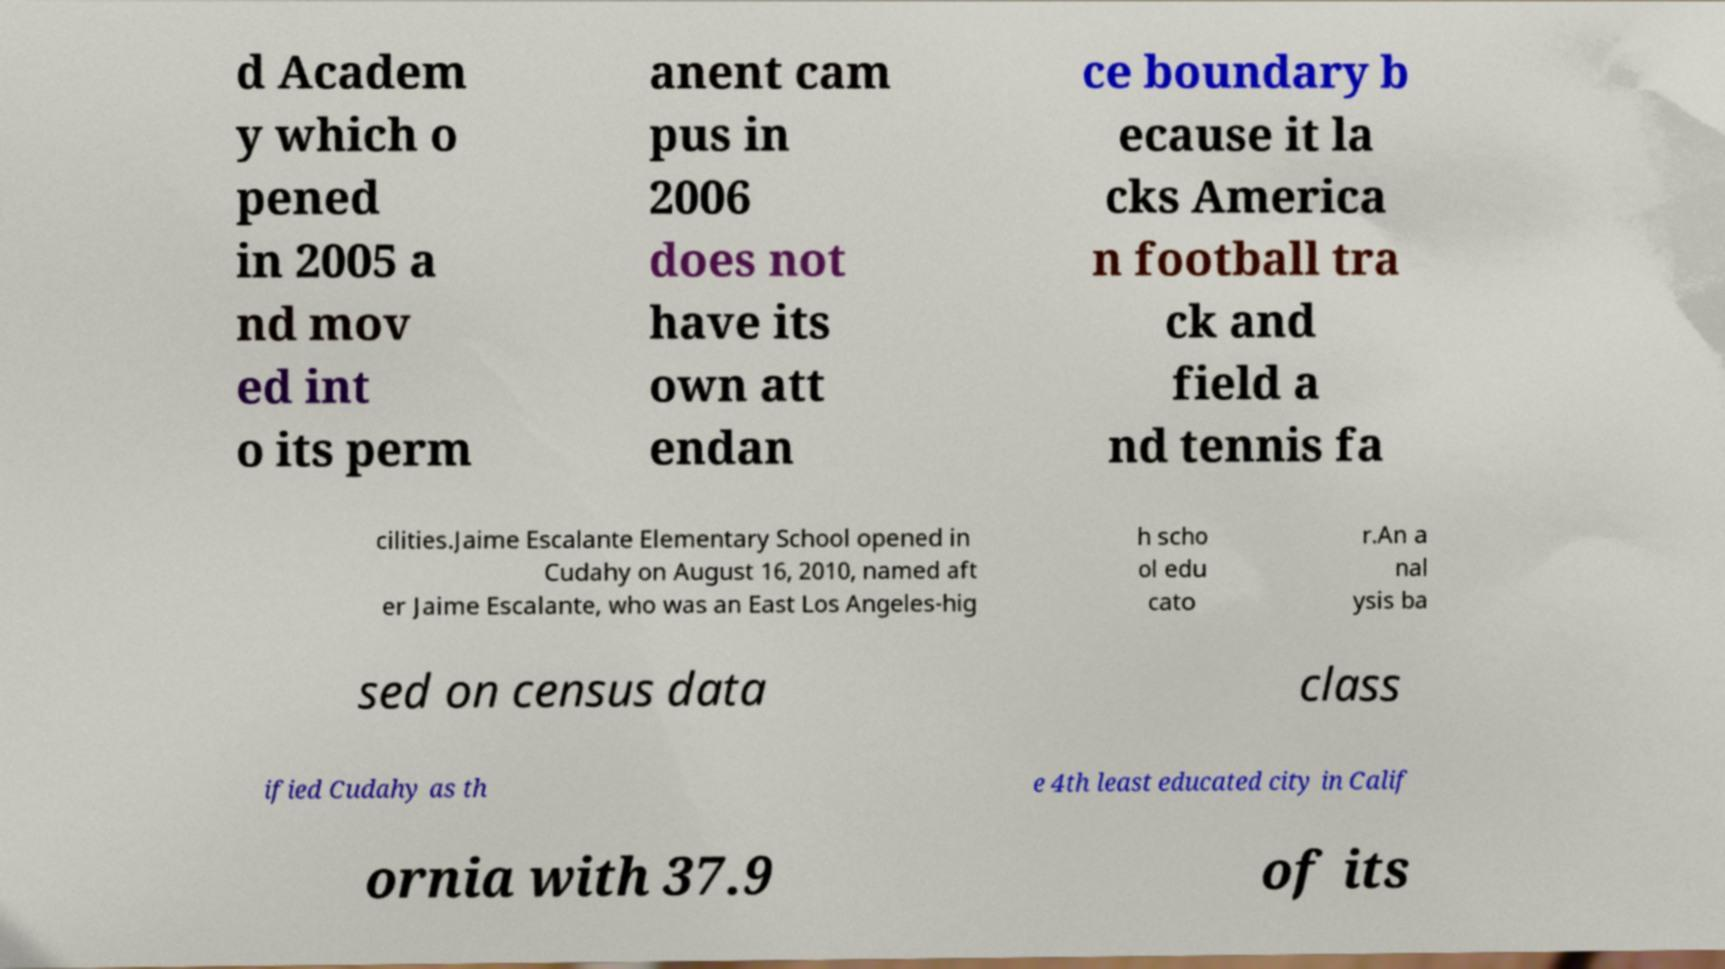Please identify and transcribe the text found in this image. d Academ y which o pened in 2005 a nd mov ed int o its perm anent cam pus in 2006 does not have its own att endan ce boundary b ecause it la cks America n football tra ck and field a nd tennis fa cilities.Jaime Escalante Elementary School opened in Cudahy on August 16, 2010, named aft er Jaime Escalante, who was an East Los Angeles-hig h scho ol edu cato r.An a nal ysis ba sed on census data class ified Cudahy as th e 4th least educated city in Calif ornia with 37.9 of its 